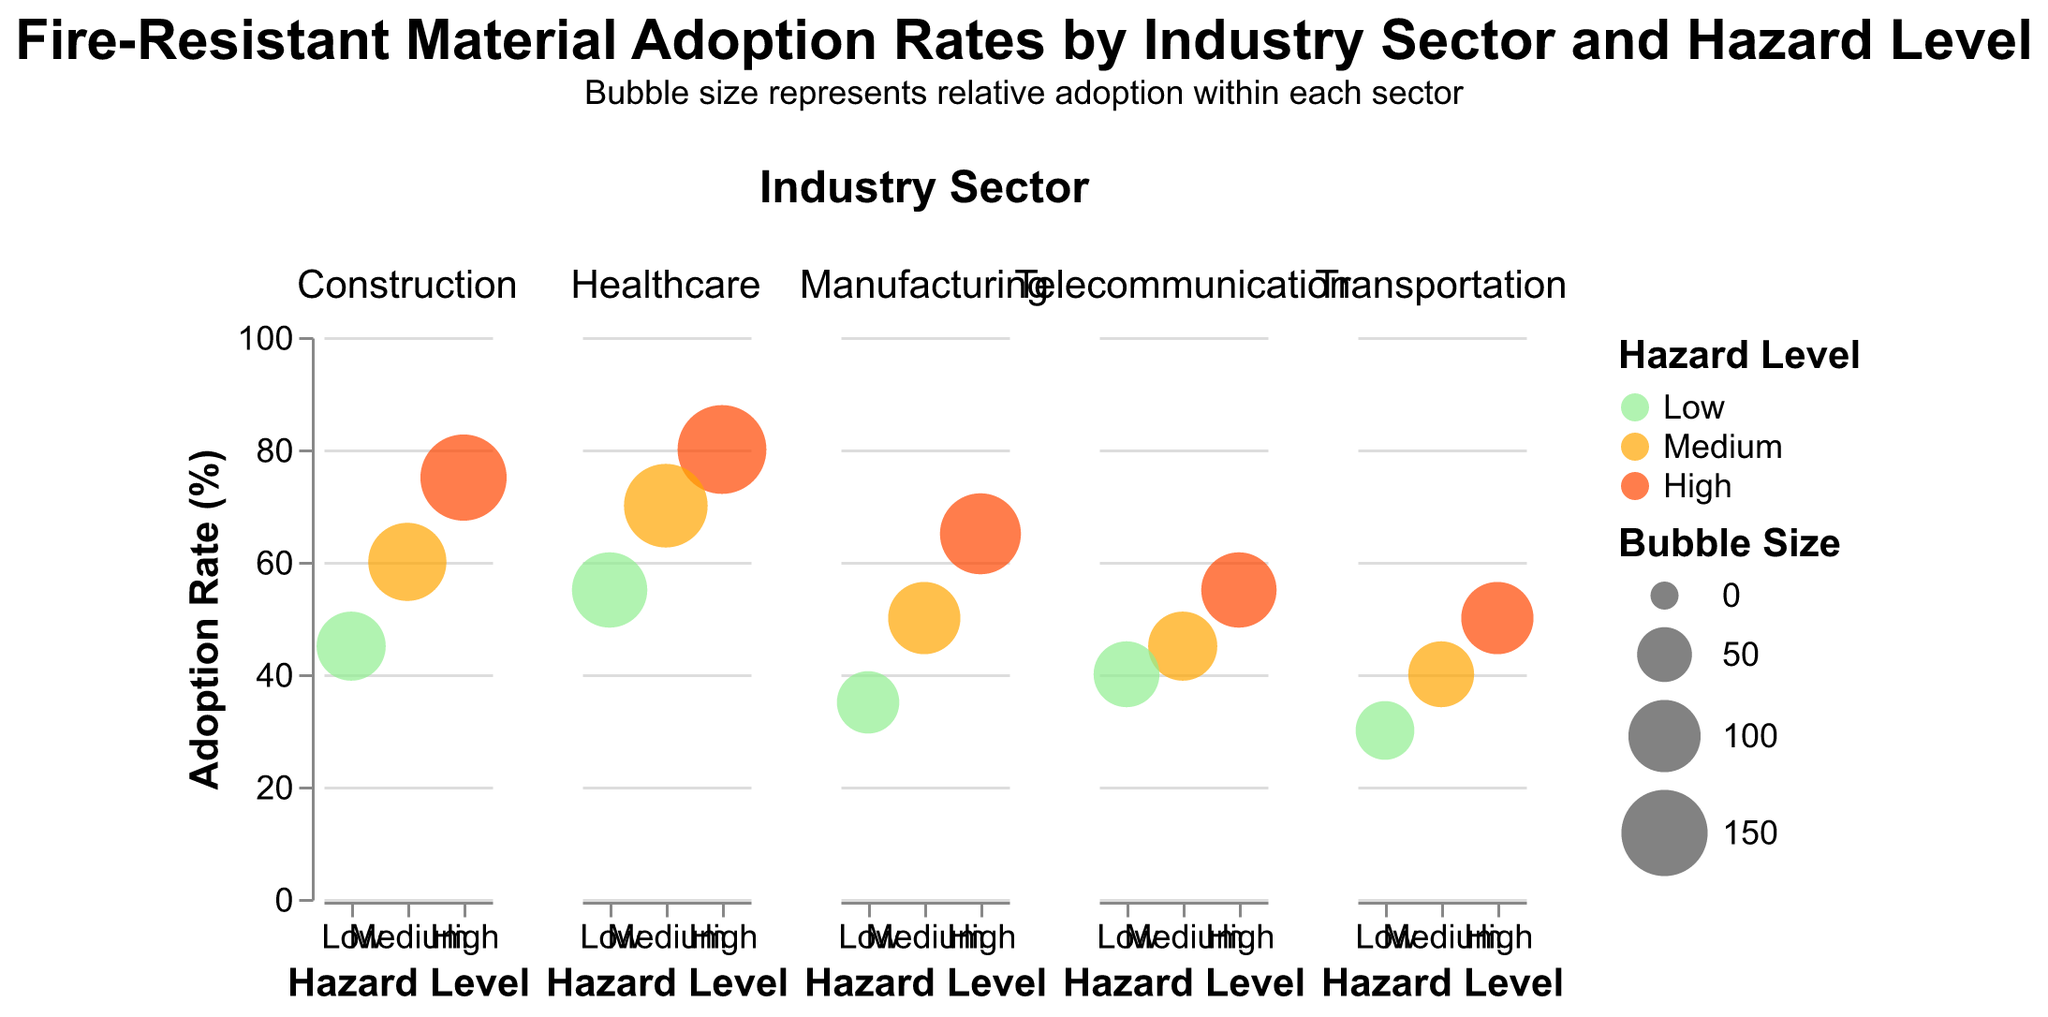What's the highest adoption rate for fire-resistant materials among all sectors? To find the highest adoption rate, look for the point with the highest value on the y-axis across all sectors. In the Construction sector with a high hazard level, the adoption rate is 75%. However, the Healthcare sector high hazard level has an adoption rate of 80%.
Answer: 80% Which industry sector has the highest adoption rate for medium hazard levels? Check the y-axis values for the medium hazard level in each sector. For the Construction sector, it is 60%. The Manufacturing sector has 50%, Healthcare sector is 70%, Transportation sector is 40%, and Telecommunication sector is 45%. The highest is in Healthcare.
Answer: Healthcare What's the difference in adoption rates between high and low hazard levels in the Healthcare sector? For high hazard levels in Healthcare, the adoption rate is 80%. For low hazard levels, it is 55%. Calculate the difference: 80% - 55% = 25%.
Answer: 25% Which sector has the smallest bubble size for the high hazard level? Compare the bubble sizes on the high hazard level across sectors. Construction is 150, Manufacturing is 130, Healthcare is 160, Transportation is 100, Telecommunication is 110. The smallest is Transportation.
Answer: Transportation In terms of adoption rates, how does the Telecommunication sector compare to the Transportation sector for low hazard levels? For Telecommunication's low hazard level, the adoption rate is 40%. For Transportation, the adoption rate is 30%. Compare 40% > 30%.
Answer: Telecommunication has a higher adoption rate Which sector exhibits the greatest variability in adoption rates across different hazard levels? Evaluate the range of adoption rates within each sector. Construction ranges from 75% to 45% (30%), Manufacturing from 65% to 35% (30%), Healthcare from 80% to 55% (25%), Transportation from 50% to 30% (20%), and Telecommunication from 55% to 40% (15%). The most variability is in Construction and Manufacturing with a 30% range.
Answer: Construction and Manufacturing Order the industry sectors by their medium hazard level adoption rates from highest to lowest. List medium hazard level adoption rates for each sector: Construction (60%), Manufacturing (50%), Healthcare (70%), Transportation (40%), Telecommunication (45%). Then order them: Healthcare > Construction > Manufacturing > Telecommunication > Transportation.
Answer: Healthcare, Construction, Manufacturing, Telecommunication, Transportation What is the average adoption rate across all hazard levels in the Manufacturing sector? The rates are 65% (high), 50% (medium), and 35% (low). Calculate the average: (65 + 50 + 35) / 3 = 50%.
Answer: 50% Compare the bubble size trends between Construction and Healthcare sectors. Which has larger bubbles on average? The bubble sizes in Construction are 150 (high), 120 (medium), 90 (low). Average = (150 + 120 + 90) / 3 = 120. In Healthcare, bubble sizes are 160 (high), 140 (medium), 110 (low). Average = (160 + 140 + 110) / 3 = 136. Healthcare has larger bubbles on average.
Answer: Healthcare Out of all sectors, which has the smallest adoption rate for high hazard levels? Compare the adoption rates for high hazard levels across all sectors. Construction is 75%, Manufacturing is 65%, Healthcare is 80%, Transportation is 50%, and Telecommunication is 55%. The smallest is in Transportation.
Answer: Transportation 